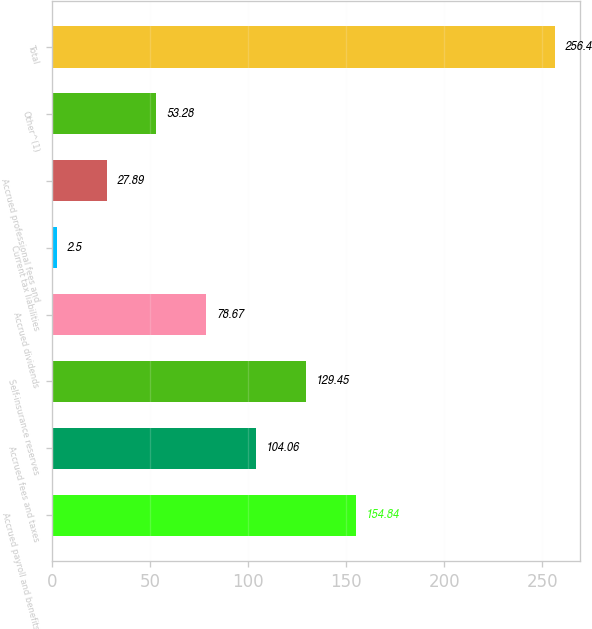Convert chart. <chart><loc_0><loc_0><loc_500><loc_500><bar_chart><fcel>Accrued payroll and benefits<fcel>Accrued fees and taxes<fcel>Self-insurance reserves<fcel>Accrued dividends<fcel>Current tax liabilities<fcel>Accrued professional fees and<fcel>Other^(1)<fcel>Total<nl><fcel>154.84<fcel>104.06<fcel>129.45<fcel>78.67<fcel>2.5<fcel>27.89<fcel>53.28<fcel>256.4<nl></chart> 